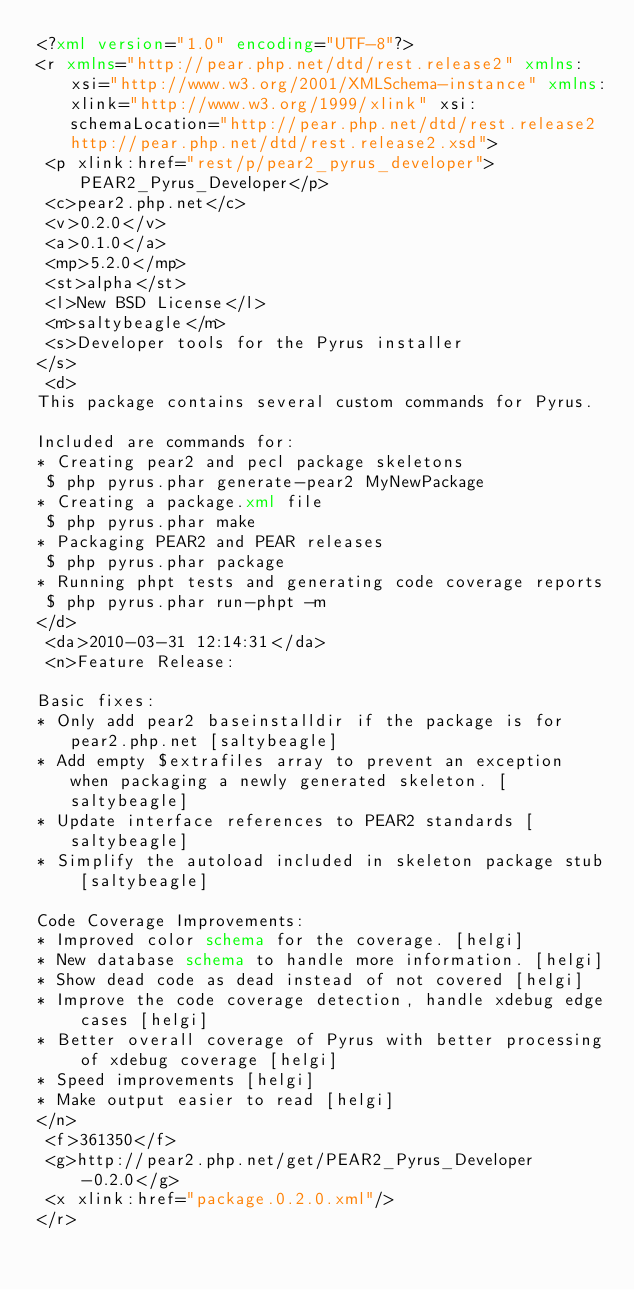<code> <loc_0><loc_0><loc_500><loc_500><_XML_><?xml version="1.0" encoding="UTF-8"?>
<r xmlns="http://pear.php.net/dtd/rest.release2" xmlns:xsi="http://www.w3.org/2001/XMLSchema-instance" xmlns:xlink="http://www.w3.org/1999/xlink" xsi:schemaLocation="http://pear.php.net/dtd/rest.release2 http://pear.php.net/dtd/rest.release2.xsd">
 <p xlink:href="rest/p/pear2_pyrus_developer">PEAR2_Pyrus_Developer</p>
 <c>pear2.php.net</c>
 <v>0.2.0</v>
 <a>0.1.0</a>
 <mp>5.2.0</mp>
 <st>alpha</st>
 <l>New BSD License</l>
 <m>saltybeagle</m>
 <s>Developer tools for the Pyrus installer
</s>
 <d>
This package contains several custom commands for Pyrus.

Included are commands for:
* Creating pear2 and pecl package skeletons
 $ php pyrus.phar generate-pear2 MyNewPackage
* Creating a package.xml file
 $ php pyrus.phar make
* Packaging PEAR2 and PEAR releases
 $ php pyrus.phar package
* Running phpt tests and generating code coverage reports
 $ php pyrus.phar run-phpt -m
</d>
 <da>2010-03-31 12:14:31</da>
 <n>Feature Release:

Basic fixes:
* Only add pear2 baseinstalldir if the package is for pear2.php.net [saltybeagle]
* Add empty $extrafiles array to prevent an exception when packaging a newly generated skeleton. [saltybeagle]
* Update interface references to PEAR2 standards [saltybeagle]
* Simplify the autoload included in skeleton package stub [saltybeagle]

Code Coverage Improvements:
* Improved color schema for the coverage. [helgi]
* New database schema to handle more information. [helgi]
* Show dead code as dead instead of not covered [helgi]
* Improve the code coverage detection, handle xdebug edge cases [helgi]
* Better overall coverage of Pyrus with better processing of xdebug coverage [helgi]
* Speed improvements [helgi]
* Make output easier to read [helgi]
</n>
 <f>361350</f>
 <g>http://pear2.php.net/get/PEAR2_Pyrus_Developer-0.2.0</g>
 <x xlink:href="package.0.2.0.xml"/>
</r>
</code> 